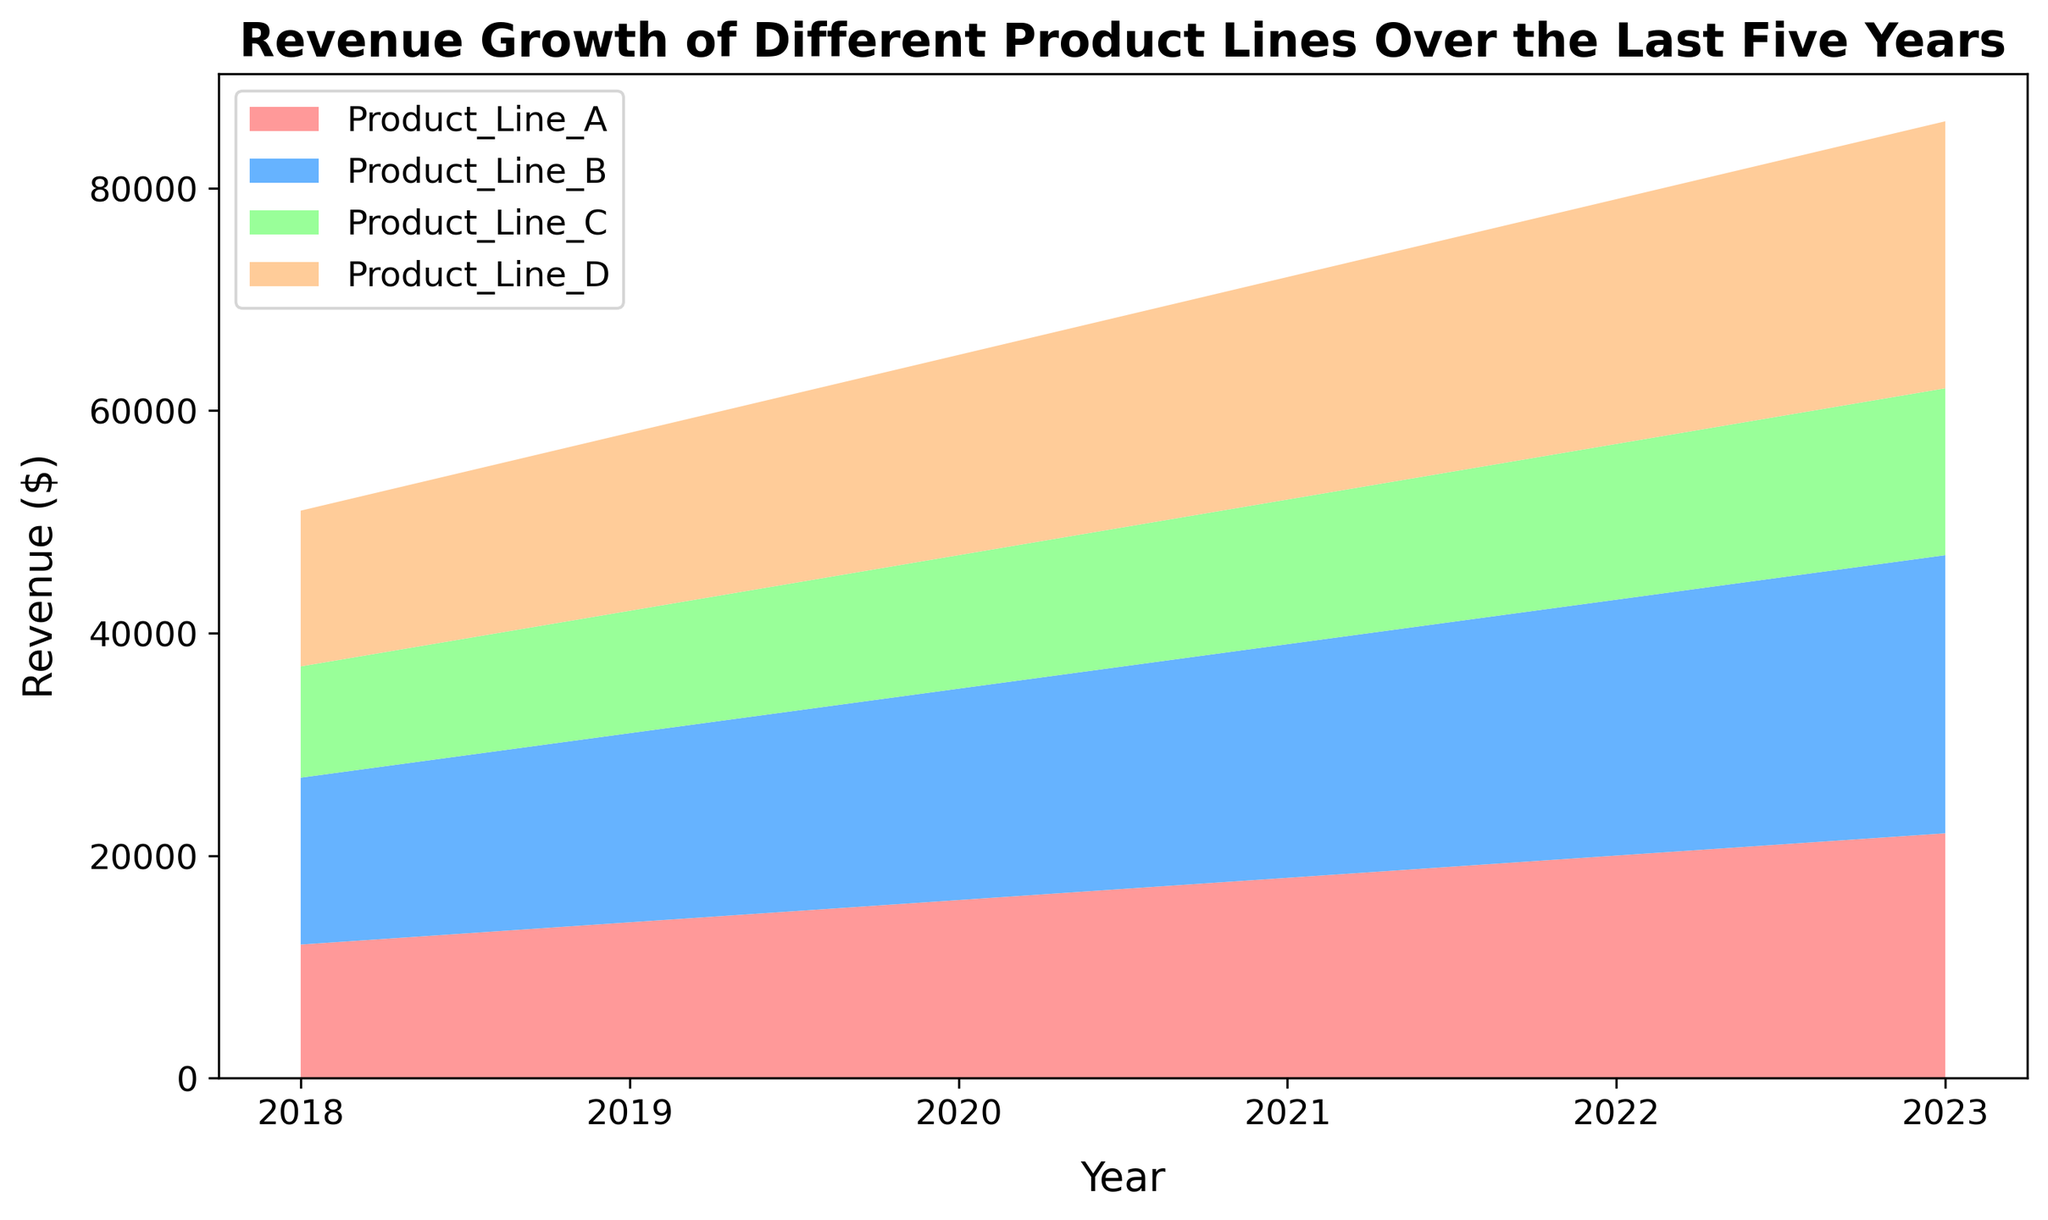What's the total revenue for Product Line A in 2020 and 2021 combined? To find the total revenue for Product Line A in 2020 and 2021, sum the values for these years. Product Line A's revenue in 2020 was $16,000 and in 2021 was $18,000. Summing these values gives $16,000 + $18,000 = $34,000.
Answer: $34,000 Which product line had the highest revenue in 2023? By looking at the figure, we find the maximum height (revenue) for 2023 in each product line. Product Line B had the highest revenue at $25,000.
Answer: Product Line B What is the average annual growth in revenue for Product Line D over the five years? To find the average annual growth for Product Line D, calculate the difference in revenue between 2023 and 2018, then divide by the number of years minus one (2023-2018 = 5 years). The revenue in 2018 was $14,000, and in 2023 it was $24,000. The growth in revenue is $24,000 - $14,000 = $10,000. The average annual growth is $10,000 / 5 = $2,000.
Answer: $2,000 Was there any year when Product Line C's revenue was higher than Product Line A's revenue? Compare the revenues of Product Line C and Product Line A for each year. There was no year when Product Line C's revenue (ranging from $10,000 to $15,000) was higher than Product Line A's revenue (ranging from $12,000 to $22,000).
Answer: No How did the revenue of Product Line B change from 2018 to 2023? By analyzing the figure, we observe the revenue of Product Line B in 2018 was $15,000, and in 2023 it was $25,000. Thus, the revenue increased by $25,000 - $15,000 = $10,000.
Answer: Increased by $10,000 Which product line showed the least revenue growth from 2018 to 2023? By comparing the growth of each product line over the period, Product Line A's revenue grew from $12,000 to $22,000 (+$10,000), Product Line B from $15,000 to $25,000 (+$10,000), Product Line C from $10,000 to $15,000 (+$5,000), and Product Line D from $14,000 to $24,000 (+$10,000). Product Line C showed the least growth of $5,000.
Answer: Product Line C In which year was the total revenue from all product lines the highest? Sum the revenues of all product lines for each year and compare. The total revenues are $51,000 in 2018, $58,000 in 2019, $65,000 in 2020, $72,000 in 2021, $79,000 in 2022, and $85,000 in 2023. The highest total revenue was in 2023, with $85,000.
Answer: 2023 What is the difference in revenue between Product Line D and Product Line C in 2022? The revenue for Product Line D in 2022 was $22,000, and for Product Line C, it was $14,000. The difference is $22,000 - $14,000 = $8,000.
Answer: $8,000 